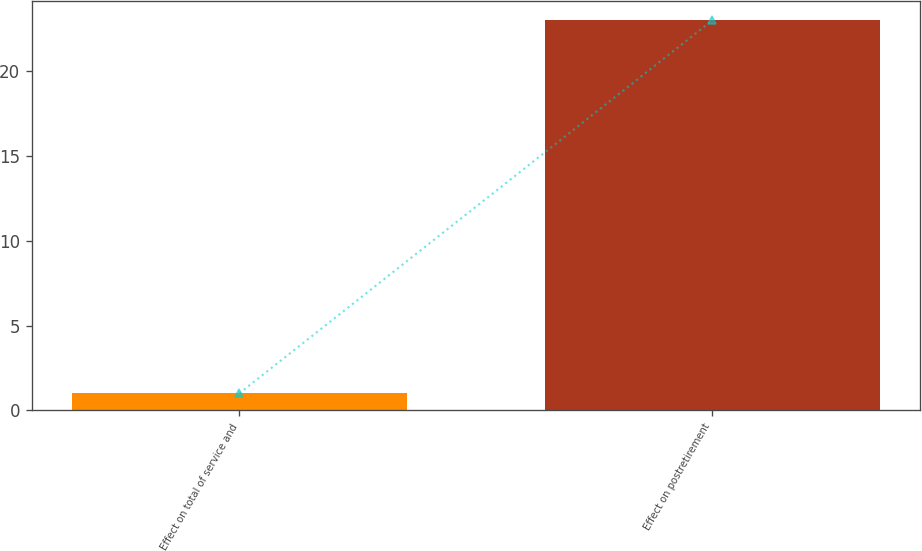Convert chart. <chart><loc_0><loc_0><loc_500><loc_500><bar_chart><fcel>Effect on total of service and<fcel>Effect on postretirement<nl><fcel>1<fcel>23<nl></chart> 